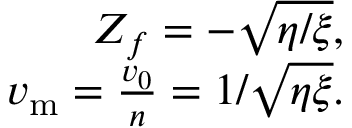<formula> <loc_0><loc_0><loc_500><loc_500>\begin{array} { r } { Z _ { f } = - \sqrt { \eta / \xi } , } \\ { v _ { m } = \frac { v _ { 0 } } { n } = 1 / \sqrt { \eta \xi } . } \end{array}</formula> 